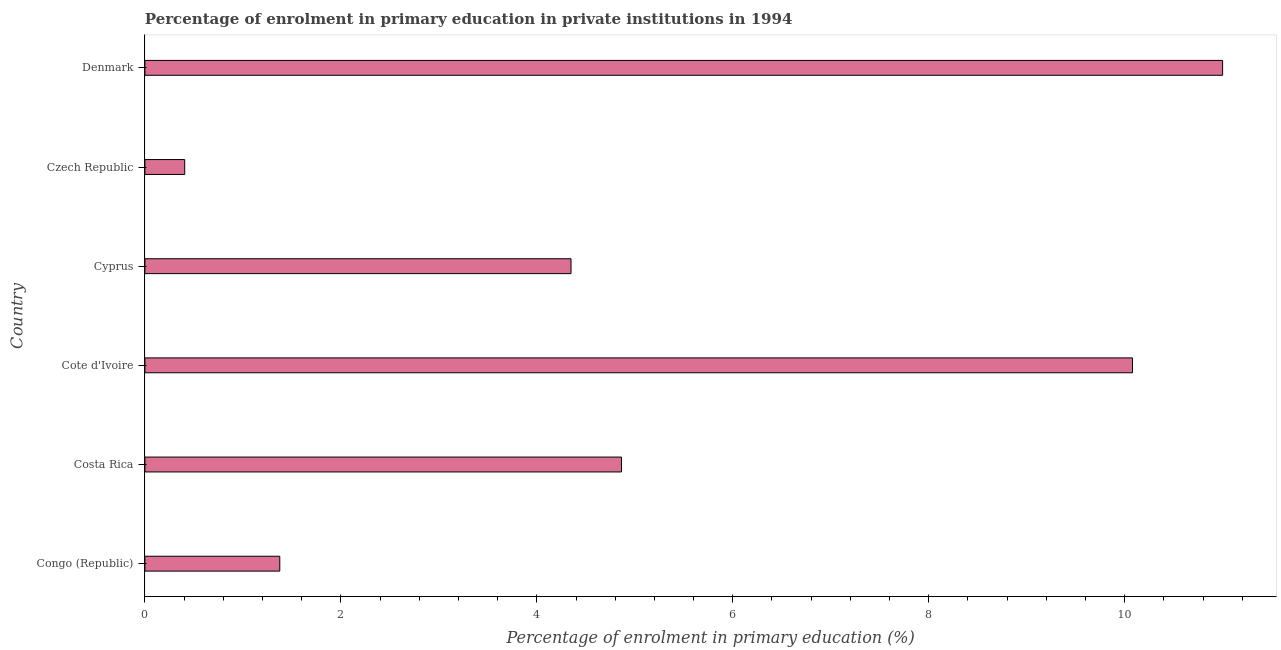Does the graph contain any zero values?
Keep it short and to the point. No. Does the graph contain grids?
Provide a short and direct response. No. What is the title of the graph?
Your answer should be compact. Percentage of enrolment in primary education in private institutions in 1994. What is the label or title of the X-axis?
Offer a terse response. Percentage of enrolment in primary education (%). What is the label or title of the Y-axis?
Provide a succinct answer. Country. What is the enrolment percentage in primary education in Cote d'Ivoire?
Offer a terse response. 10.08. Across all countries, what is the maximum enrolment percentage in primary education?
Offer a terse response. 11. Across all countries, what is the minimum enrolment percentage in primary education?
Your response must be concise. 0.41. In which country was the enrolment percentage in primary education minimum?
Your answer should be compact. Czech Republic. What is the sum of the enrolment percentage in primary education?
Make the answer very short. 32.08. What is the difference between the enrolment percentage in primary education in Congo (Republic) and Cyprus?
Your response must be concise. -2.97. What is the average enrolment percentage in primary education per country?
Make the answer very short. 5.35. What is the median enrolment percentage in primary education?
Offer a terse response. 4.61. In how many countries, is the enrolment percentage in primary education greater than 4.4 %?
Offer a terse response. 3. What is the ratio of the enrolment percentage in primary education in Costa Rica to that in Cyprus?
Make the answer very short. 1.12. Is the enrolment percentage in primary education in Congo (Republic) less than that in Costa Rica?
Provide a succinct answer. Yes. What is the difference between the highest and the lowest enrolment percentage in primary education?
Keep it short and to the point. 10.59. In how many countries, is the enrolment percentage in primary education greater than the average enrolment percentage in primary education taken over all countries?
Your answer should be compact. 2. How many bars are there?
Provide a succinct answer. 6. Are all the bars in the graph horizontal?
Ensure brevity in your answer.  Yes. How many countries are there in the graph?
Give a very brief answer. 6. What is the difference between two consecutive major ticks on the X-axis?
Offer a very short reply. 2. Are the values on the major ticks of X-axis written in scientific E-notation?
Keep it short and to the point. No. What is the Percentage of enrolment in primary education (%) in Congo (Republic)?
Offer a terse response. 1.38. What is the Percentage of enrolment in primary education (%) of Costa Rica?
Ensure brevity in your answer.  4.86. What is the Percentage of enrolment in primary education (%) of Cote d'Ivoire?
Your answer should be compact. 10.08. What is the Percentage of enrolment in primary education (%) of Cyprus?
Your answer should be compact. 4.35. What is the Percentage of enrolment in primary education (%) in Czech Republic?
Your response must be concise. 0.41. What is the Percentage of enrolment in primary education (%) of Denmark?
Ensure brevity in your answer.  11. What is the difference between the Percentage of enrolment in primary education (%) in Congo (Republic) and Costa Rica?
Keep it short and to the point. -3.49. What is the difference between the Percentage of enrolment in primary education (%) in Congo (Republic) and Cote d'Ivoire?
Give a very brief answer. -8.7. What is the difference between the Percentage of enrolment in primary education (%) in Congo (Republic) and Cyprus?
Your answer should be very brief. -2.97. What is the difference between the Percentage of enrolment in primary education (%) in Congo (Republic) and Czech Republic?
Your answer should be very brief. 0.97. What is the difference between the Percentage of enrolment in primary education (%) in Congo (Republic) and Denmark?
Your answer should be compact. -9.62. What is the difference between the Percentage of enrolment in primary education (%) in Costa Rica and Cote d'Ivoire?
Offer a terse response. -5.22. What is the difference between the Percentage of enrolment in primary education (%) in Costa Rica and Cyprus?
Provide a succinct answer. 0.51. What is the difference between the Percentage of enrolment in primary education (%) in Costa Rica and Czech Republic?
Provide a short and direct response. 4.46. What is the difference between the Percentage of enrolment in primary education (%) in Costa Rica and Denmark?
Your response must be concise. -6.14. What is the difference between the Percentage of enrolment in primary education (%) in Cote d'Ivoire and Cyprus?
Offer a terse response. 5.73. What is the difference between the Percentage of enrolment in primary education (%) in Cote d'Ivoire and Czech Republic?
Keep it short and to the point. 9.67. What is the difference between the Percentage of enrolment in primary education (%) in Cote d'Ivoire and Denmark?
Provide a succinct answer. -0.92. What is the difference between the Percentage of enrolment in primary education (%) in Cyprus and Czech Republic?
Keep it short and to the point. 3.94. What is the difference between the Percentage of enrolment in primary education (%) in Cyprus and Denmark?
Keep it short and to the point. -6.65. What is the difference between the Percentage of enrolment in primary education (%) in Czech Republic and Denmark?
Make the answer very short. -10.59. What is the ratio of the Percentage of enrolment in primary education (%) in Congo (Republic) to that in Costa Rica?
Make the answer very short. 0.28. What is the ratio of the Percentage of enrolment in primary education (%) in Congo (Republic) to that in Cote d'Ivoire?
Make the answer very short. 0.14. What is the ratio of the Percentage of enrolment in primary education (%) in Congo (Republic) to that in Cyprus?
Your response must be concise. 0.32. What is the ratio of the Percentage of enrolment in primary education (%) in Congo (Republic) to that in Czech Republic?
Provide a succinct answer. 3.39. What is the ratio of the Percentage of enrolment in primary education (%) in Congo (Republic) to that in Denmark?
Make the answer very short. 0.12. What is the ratio of the Percentage of enrolment in primary education (%) in Costa Rica to that in Cote d'Ivoire?
Offer a terse response. 0.48. What is the ratio of the Percentage of enrolment in primary education (%) in Costa Rica to that in Cyprus?
Make the answer very short. 1.12. What is the ratio of the Percentage of enrolment in primary education (%) in Costa Rica to that in Czech Republic?
Your answer should be compact. 11.97. What is the ratio of the Percentage of enrolment in primary education (%) in Costa Rica to that in Denmark?
Provide a succinct answer. 0.44. What is the ratio of the Percentage of enrolment in primary education (%) in Cote d'Ivoire to that in Cyprus?
Your response must be concise. 2.32. What is the ratio of the Percentage of enrolment in primary education (%) in Cote d'Ivoire to that in Czech Republic?
Ensure brevity in your answer.  24.81. What is the ratio of the Percentage of enrolment in primary education (%) in Cote d'Ivoire to that in Denmark?
Provide a short and direct response. 0.92. What is the ratio of the Percentage of enrolment in primary education (%) in Cyprus to that in Czech Republic?
Keep it short and to the point. 10.71. What is the ratio of the Percentage of enrolment in primary education (%) in Cyprus to that in Denmark?
Your answer should be compact. 0.4. What is the ratio of the Percentage of enrolment in primary education (%) in Czech Republic to that in Denmark?
Your answer should be very brief. 0.04. 